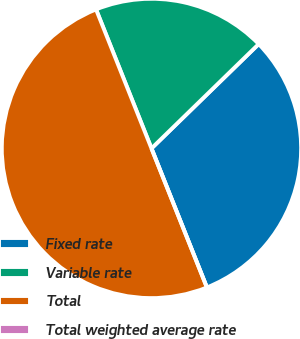Convert chart to OTSL. <chart><loc_0><loc_0><loc_500><loc_500><pie_chart><fcel>Fixed rate<fcel>Variable rate<fcel>Total<fcel>Total weighted average rate<nl><fcel>31.25%<fcel>18.75%<fcel>50.0%<fcel>0.0%<nl></chart> 